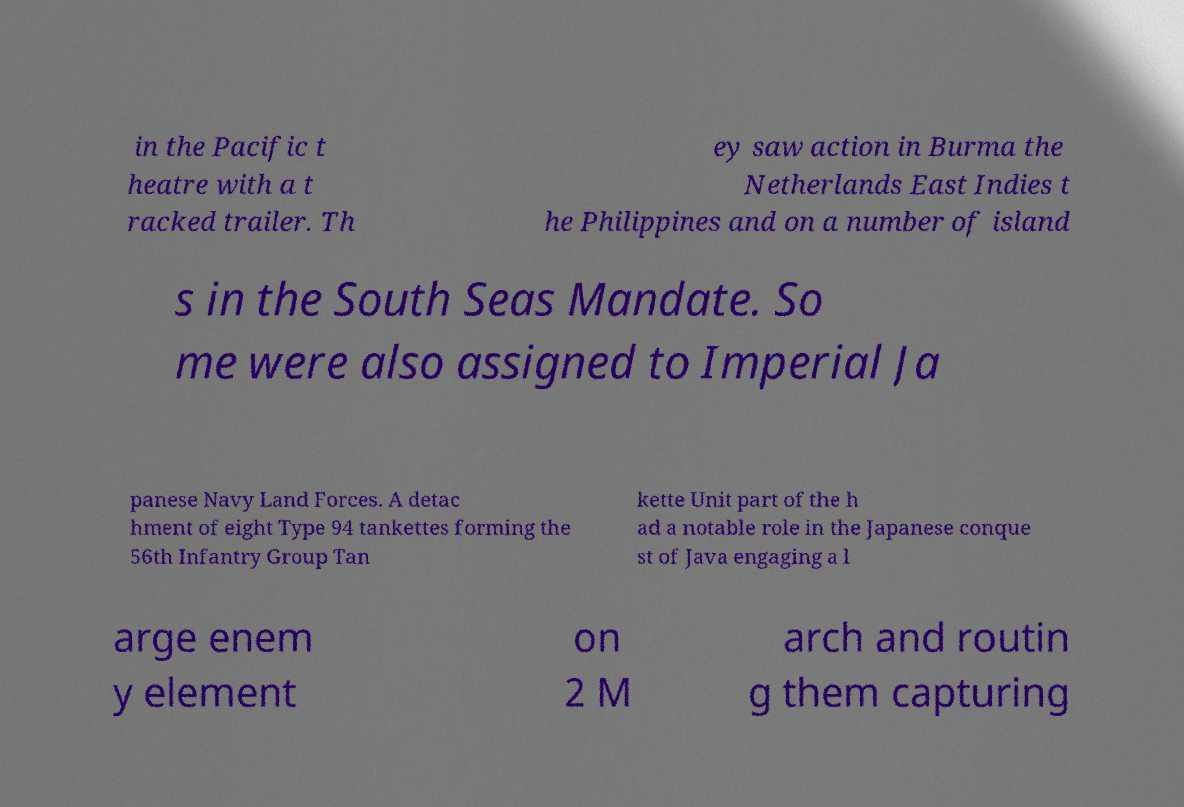Could you extract and type out the text from this image? in the Pacific t heatre with a t racked trailer. Th ey saw action in Burma the Netherlands East Indies t he Philippines and on a number of island s in the South Seas Mandate. So me were also assigned to Imperial Ja panese Navy Land Forces. A detac hment of eight Type 94 tankettes forming the 56th Infantry Group Tan kette Unit part of the h ad a notable role in the Japanese conque st of Java engaging a l arge enem y element on 2 M arch and routin g them capturing 